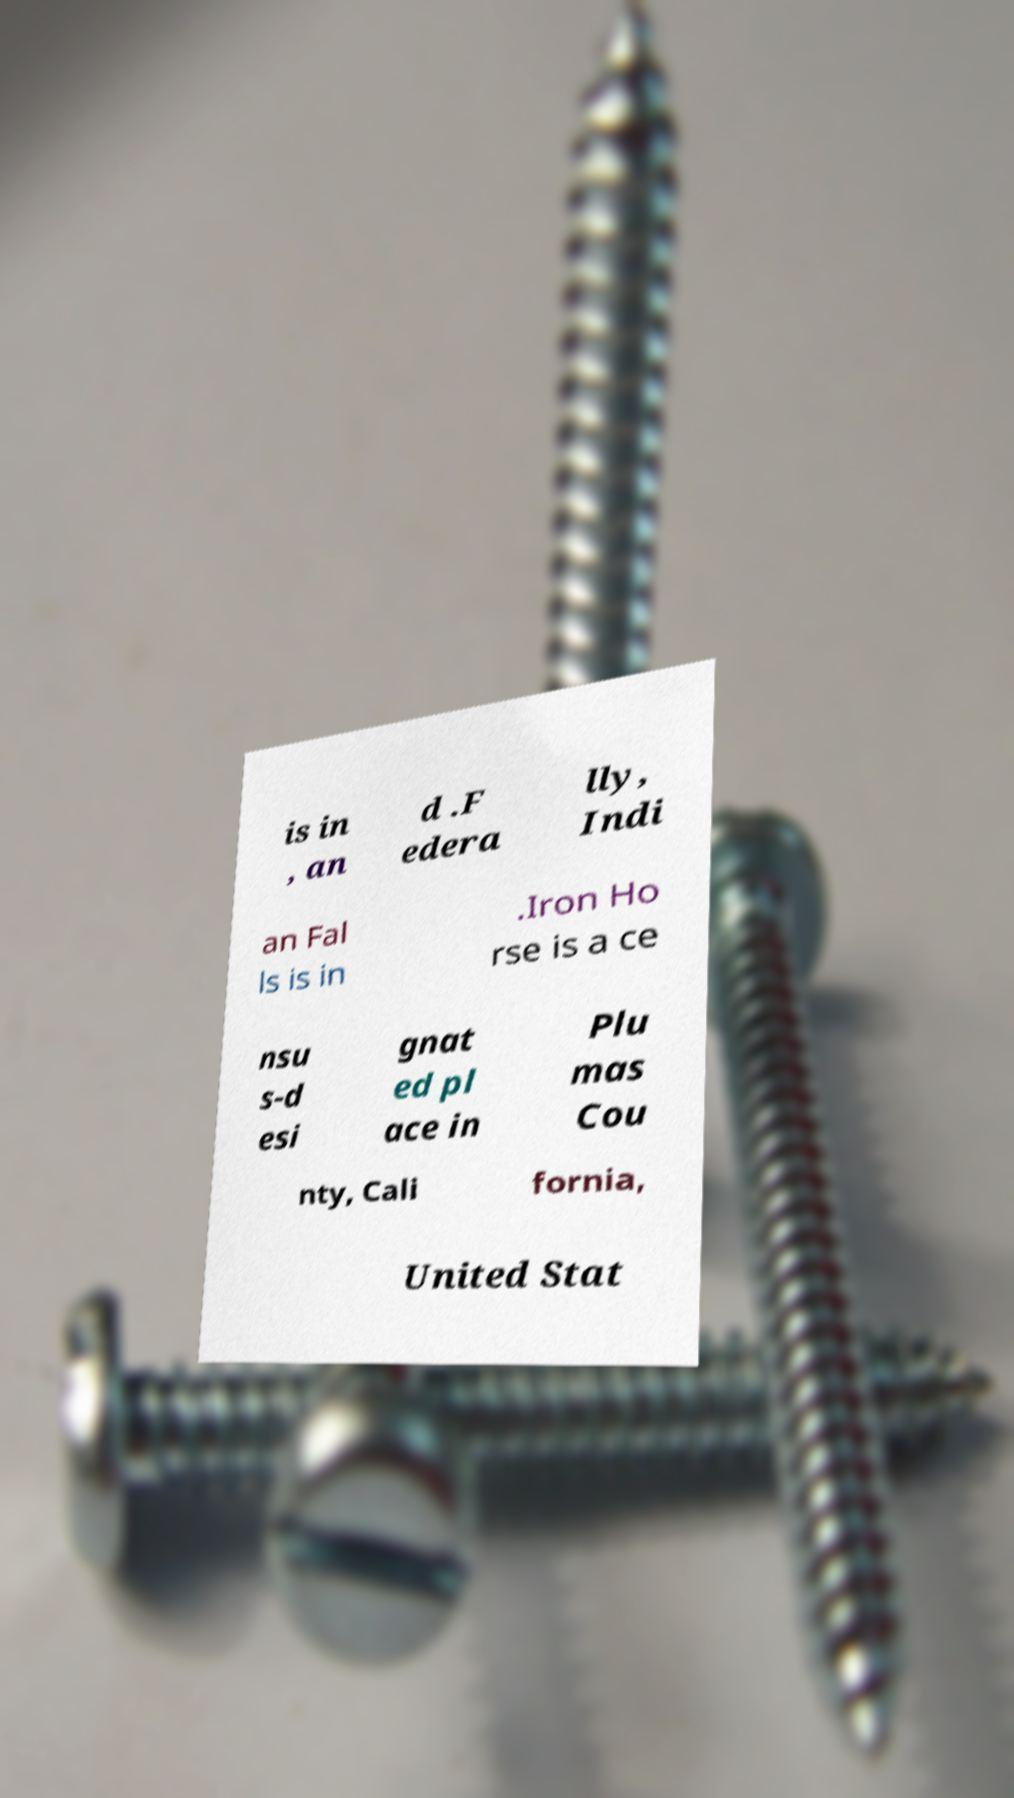Please read and relay the text visible in this image. What does it say? is in , an d .F edera lly, Indi an Fal ls is in .Iron Ho rse is a ce nsu s-d esi gnat ed pl ace in Plu mas Cou nty, Cali fornia, United Stat 